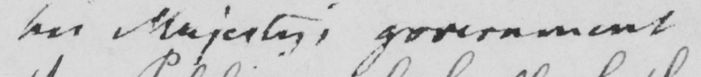What text is written in this handwritten line? her Majesty ' s government 